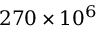Convert formula to latex. <formula><loc_0><loc_0><loc_500><loc_500>2 7 0 \times 1 0 ^ { 6 }</formula> 